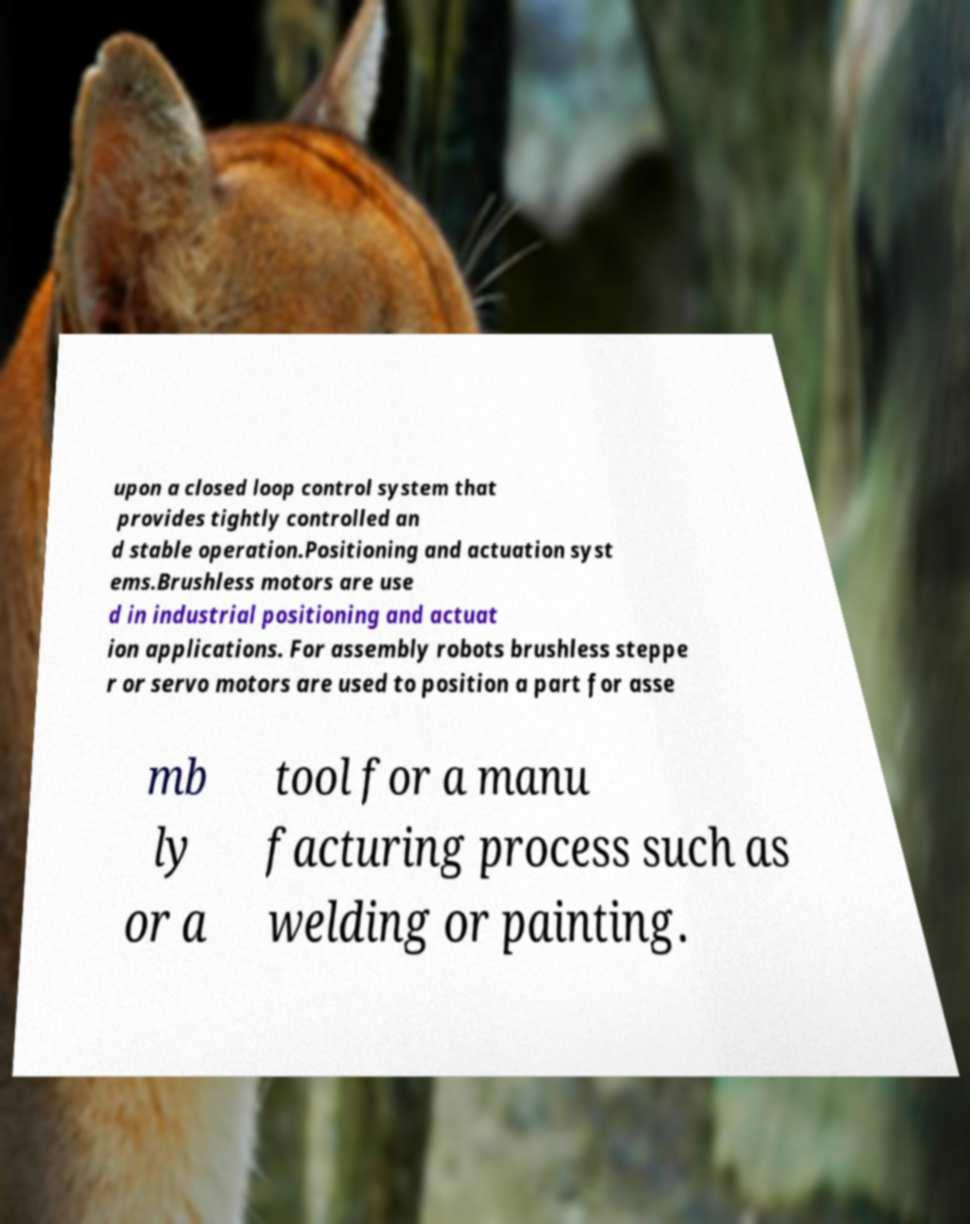I need the written content from this picture converted into text. Can you do that? upon a closed loop control system that provides tightly controlled an d stable operation.Positioning and actuation syst ems.Brushless motors are use d in industrial positioning and actuat ion applications. For assembly robots brushless steppe r or servo motors are used to position a part for asse mb ly or a tool for a manu facturing process such as welding or painting. 